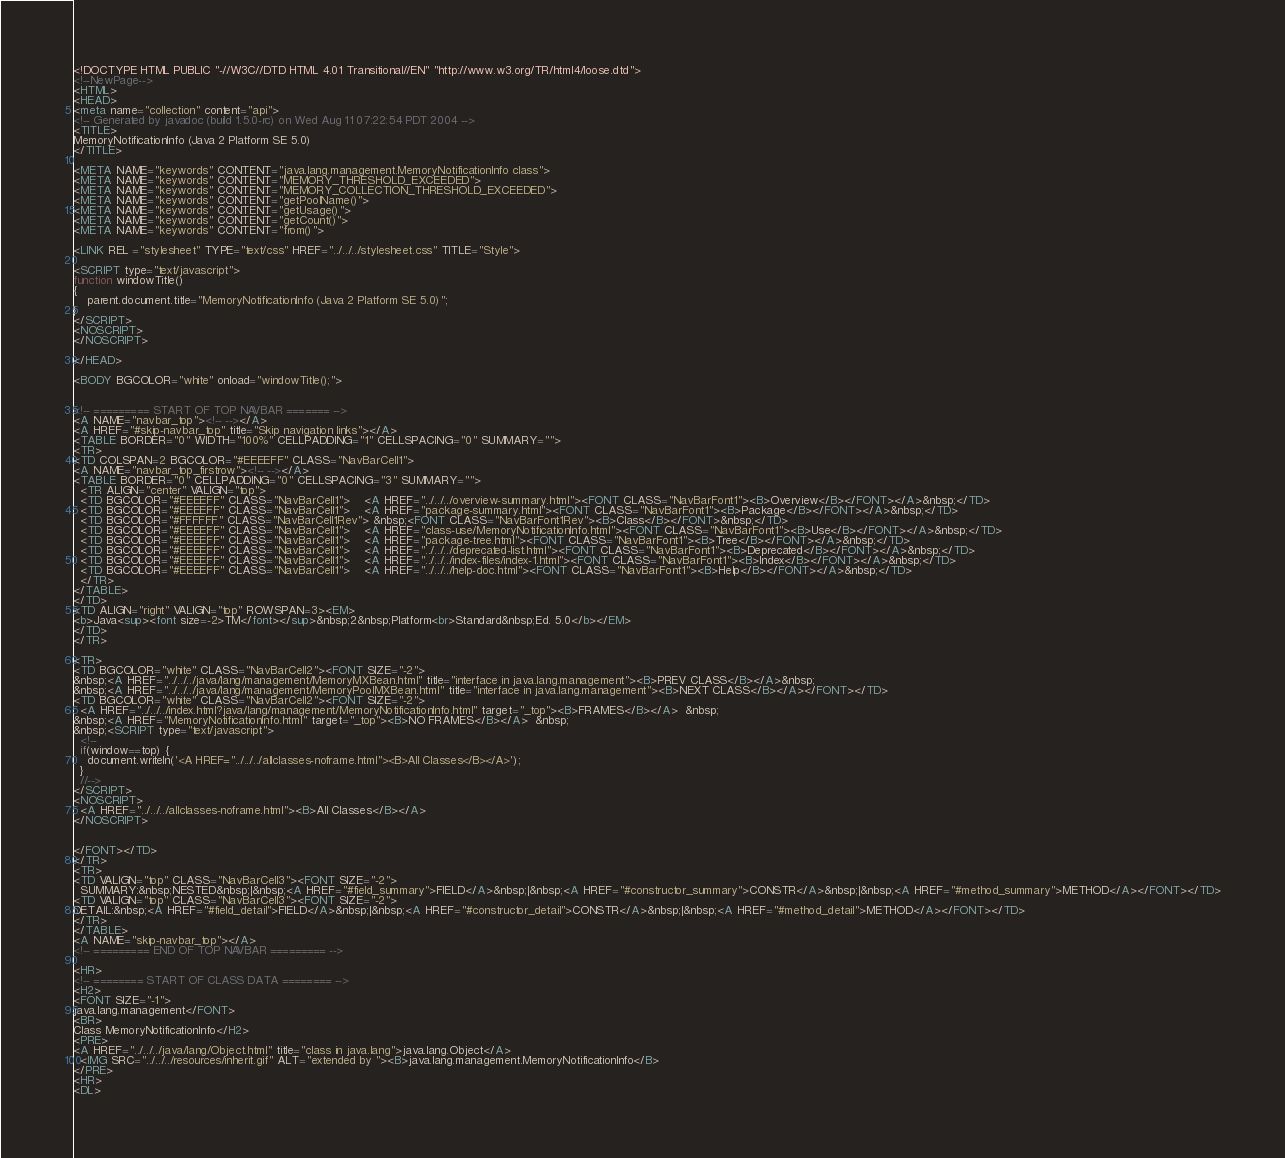Convert code to text. <code><loc_0><loc_0><loc_500><loc_500><_HTML_><!DOCTYPE HTML PUBLIC "-//W3C//DTD HTML 4.01 Transitional//EN" "http://www.w3.org/TR/html4/loose.dtd">
<!--NewPage-->
<HTML>
<HEAD>
<meta name="collection" content="api">
<!-- Generated by javadoc (build 1.5.0-rc) on Wed Aug 11 07:22:54 PDT 2004 -->
<TITLE>
MemoryNotificationInfo (Java 2 Platform SE 5.0)
</TITLE>

<META NAME="keywords" CONTENT="java.lang.management.MemoryNotificationInfo class">
<META NAME="keywords" CONTENT="MEMORY_THRESHOLD_EXCEEDED">
<META NAME="keywords" CONTENT="MEMORY_COLLECTION_THRESHOLD_EXCEEDED">
<META NAME="keywords" CONTENT="getPoolName()">
<META NAME="keywords" CONTENT="getUsage()">
<META NAME="keywords" CONTENT="getCount()">
<META NAME="keywords" CONTENT="from()">

<LINK REL ="stylesheet" TYPE="text/css" HREF="../../../stylesheet.css" TITLE="Style">

<SCRIPT type="text/javascript">
function windowTitle()
{
    parent.document.title="MemoryNotificationInfo (Java 2 Platform SE 5.0)";
}
</SCRIPT>
<NOSCRIPT>
</NOSCRIPT>

</HEAD>

<BODY BGCOLOR="white" onload="windowTitle();">


<!-- ========= START OF TOP NAVBAR ======= -->
<A NAME="navbar_top"><!-- --></A>
<A HREF="#skip-navbar_top" title="Skip navigation links"></A>
<TABLE BORDER="0" WIDTH="100%" CELLPADDING="1" CELLSPACING="0" SUMMARY="">
<TR>
<TD COLSPAN=2 BGCOLOR="#EEEEFF" CLASS="NavBarCell1">
<A NAME="navbar_top_firstrow"><!-- --></A>
<TABLE BORDER="0" CELLPADDING="0" CELLSPACING="3" SUMMARY="">
  <TR ALIGN="center" VALIGN="top">
  <TD BGCOLOR="#EEEEFF" CLASS="NavBarCell1">    <A HREF="../../../overview-summary.html"><FONT CLASS="NavBarFont1"><B>Overview</B></FONT></A>&nbsp;</TD>
  <TD BGCOLOR="#EEEEFF" CLASS="NavBarCell1">    <A HREF="package-summary.html"><FONT CLASS="NavBarFont1"><B>Package</B></FONT></A>&nbsp;</TD>
  <TD BGCOLOR="#FFFFFF" CLASS="NavBarCell1Rev"> &nbsp;<FONT CLASS="NavBarFont1Rev"><B>Class</B></FONT>&nbsp;</TD>
  <TD BGCOLOR="#EEEEFF" CLASS="NavBarCell1">    <A HREF="class-use/MemoryNotificationInfo.html"><FONT CLASS="NavBarFont1"><B>Use</B></FONT></A>&nbsp;</TD>
  <TD BGCOLOR="#EEEEFF" CLASS="NavBarCell1">    <A HREF="package-tree.html"><FONT CLASS="NavBarFont1"><B>Tree</B></FONT></A>&nbsp;</TD>
  <TD BGCOLOR="#EEEEFF" CLASS="NavBarCell1">    <A HREF="../../../deprecated-list.html"><FONT CLASS="NavBarFont1"><B>Deprecated</B></FONT></A>&nbsp;</TD>
  <TD BGCOLOR="#EEEEFF" CLASS="NavBarCell1">    <A HREF="../../../index-files/index-1.html"><FONT CLASS="NavBarFont1"><B>Index</B></FONT></A>&nbsp;</TD>
  <TD BGCOLOR="#EEEEFF" CLASS="NavBarCell1">    <A HREF="../../../help-doc.html"><FONT CLASS="NavBarFont1"><B>Help</B></FONT></A>&nbsp;</TD>
  </TR>
</TABLE>
</TD>
<TD ALIGN="right" VALIGN="top" ROWSPAN=3><EM>
<b>Java<sup><font size=-2>TM</font></sup>&nbsp;2&nbsp;Platform<br>Standard&nbsp;Ed. 5.0</b></EM>
</TD>
</TR>

<TR>
<TD BGCOLOR="white" CLASS="NavBarCell2"><FONT SIZE="-2">
&nbsp;<A HREF="../../../java/lang/management/MemoryMXBean.html" title="interface in java.lang.management"><B>PREV CLASS</B></A>&nbsp;
&nbsp;<A HREF="../../../java/lang/management/MemoryPoolMXBean.html" title="interface in java.lang.management"><B>NEXT CLASS</B></A></FONT></TD>
<TD BGCOLOR="white" CLASS="NavBarCell2"><FONT SIZE="-2">
  <A HREF="../../../index.html?java/lang/management/MemoryNotificationInfo.html" target="_top"><B>FRAMES</B></A>  &nbsp;
&nbsp;<A HREF="MemoryNotificationInfo.html" target="_top"><B>NO FRAMES</B></A>  &nbsp;
&nbsp;<SCRIPT type="text/javascript">
  <!--
  if(window==top) {
    document.writeln('<A HREF="../../../allclasses-noframe.html"><B>All Classes</B></A>');
  }
  //-->
</SCRIPT>
<NOSCRIPT>
  <A HREF="../../../allclasses-noframe.html"><B>All Classes</B></A>
</NOSCRIPT>


</FONT></TD>
</TR>
<TR>
<TD VALIGN="top" CLASS="NavBarCell3"><FONT SIZE="-2">
  SUMMARY:&nbsp;NESTED&nbsp;|&nbsp;<A HREF="#field_summary">FIELD</A>&nbsp;|&nbsp;<A HREF="#constructor_summary">CONSTR</A>&nbsp;|&nbsp;<A HREF="#method_summary">METHOD</A></FONT></TD>
<TD VALIGN="top" CLASS="NavBarCell3"><FONT SIZE="-2">
DETAIL:&nbsp;<A HREF="#field_detail">FIELD</A>&nbsp;|&nbsp;<A HREF="#constructor_detail">CONSTR</A>&nbsp;|&nbsp;<A HREF="#method_detail">METHOD</A></FONT></TD>
</TR>
</TABLE>
<A NAME="skip-navbar_top"></A>
<!-- ========= END OF TOP NAVBAR ========= -->

<HR>
<!-- ======== START OF CLASS DATA ======== -->
<H2>
<FONT SIZE="-1">
java.lang.management</FONT>
<BR>
Class MemoryNotificationInfo</H2>
<PRE>
<A HREF="../../../java/lang/Object.html" title="class in java.lang">java.lang.Object</A>
  <IMG SRC="../../../resources/inherit.gif" ALT="extended by "><B>java.lang.management.MemoryNotificationInfo</B>
</PRE>
<HR>
<DL></code> 